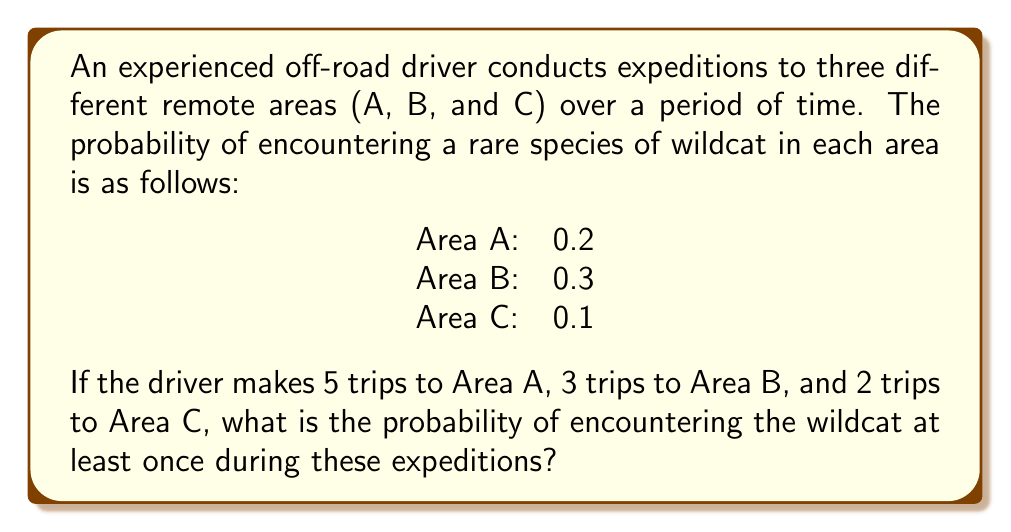Give your solution to this math problem. Let's approach this step-by-step:

1) First, let's calculate the probability of not encountering the wildcat in each area:
   Area A: $1 - 0.2 = 0.8$
   Area B: $1 - 0.3 = 0.7$
   Area C: $1 - 0.1 = 0.9$

2) Now, we need to calculate the probability of not encountering the wildcat in multiple trips to each area:
   Area A (5 trips): $0.8^5 = 0.32768$
   Area B (3 trips): $0.7^3 = 0.343$
   Area C (2 trips): $0.9^2 = 0.81$

3) The probability of not encountering the wildcat in any of the trips is the product of these probabilities:
   $P(\text{no encounter}) = 0.32768 \times 0.343 \times 0.81 = 0.09098$

4) Therefore, the probability of encountering the wildcat at least once is:
   $P(\text{at least one encounter}) = 1 - P(\text{no encounter}) = 1 - 0.09098 = 0.90902$

5) This can be rounded to 0.9090 or expressed as a percentage: 90.90%
Answer: $0.9090$ or $90.90\%$ 